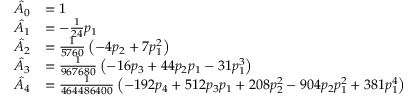<formula> <loc_0><loc_0><loc_500><loc_500>{ \begin{array} { r l } { { \hat { A } } _ { 0 } } & { = 1 } \\ { { \hat { A } } _ { 1 } } & { = - { \frac { 1 } { 2 4 } } p _ { 1 } } \\ { { \hat { A } } _ { 2 } } & { = { \frac { 1 } { 5 7 6 0 } } \left ( - 4 p _ { 2 } + 7 p _ { 1 } ^ { 2 } \right ) } \\ { { \hat { A } } _ { 3 } } & { = { \frac { 1 } { 9 6 7 6 8 0 } } \left ( - 1 6 p _ { 3 } + 4 4 p _ { 2 } p _ { 1 } - 3 1 p _ { 1 } ^ { 3 } \right ) } \\ { { \hat { A } } _ { 4 } } & { = { \frac { 1 } { 4 6 4 4 8 6 4 0 0 } } \left ( - 1 9 2 p _ { 4 } + 5 1 2 p _ { 3 } p _ { 1 } + 2 0 8 p _ { 2 } ^ { 2 } - 9 0 4 p _ { 2 } p _ { 1 } ^ { 2 } + 3 8 1 p _ { 1 } ^ { 4 } \right ) } \end{array} }</formula> 